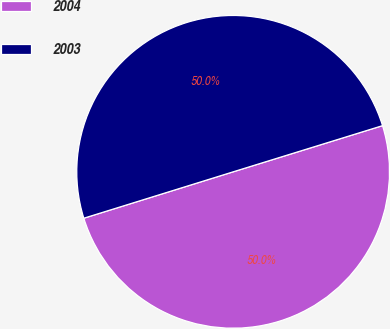<chart> <loc_0><loc_0><loc_500><loc_500><pie_chart><fcel>2004<fcel>2003<nl><fcel>49.98%<fcel>50.02%<nl></chart> 